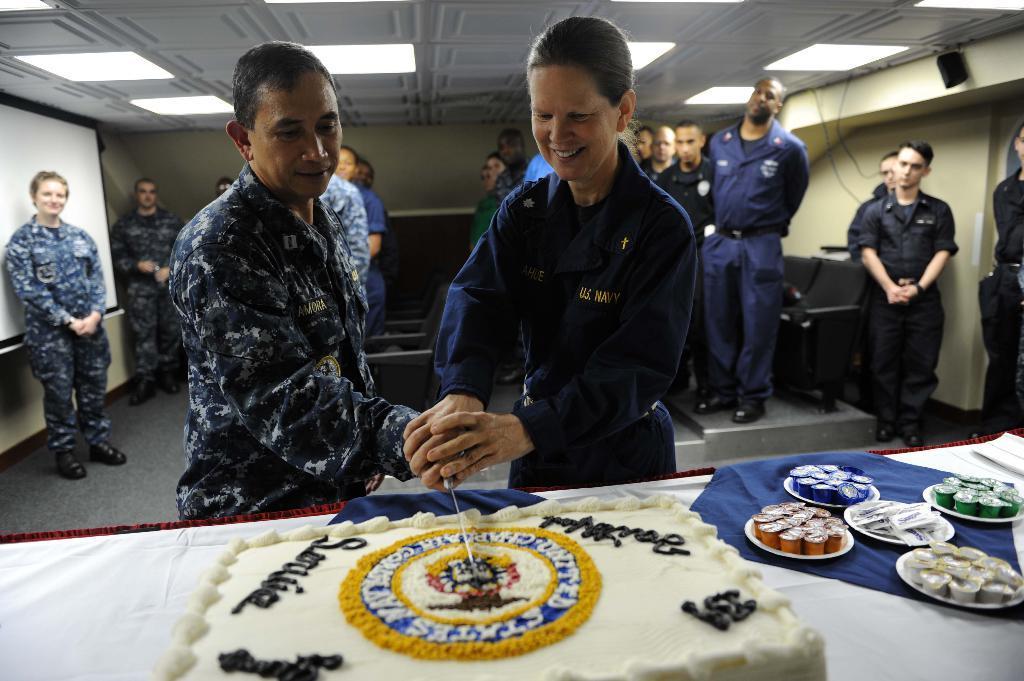Please provide a concise description of this image. In the center of the image we can see a man and a lady standing and holding a knife. At the bottom there is a table and we can see a cake, chocolates, plates, napkins placed on the table. In the background there are people standing. They are all wearing uniforms. On the left there is a screen. At the top there are lights and we can see a wall. 